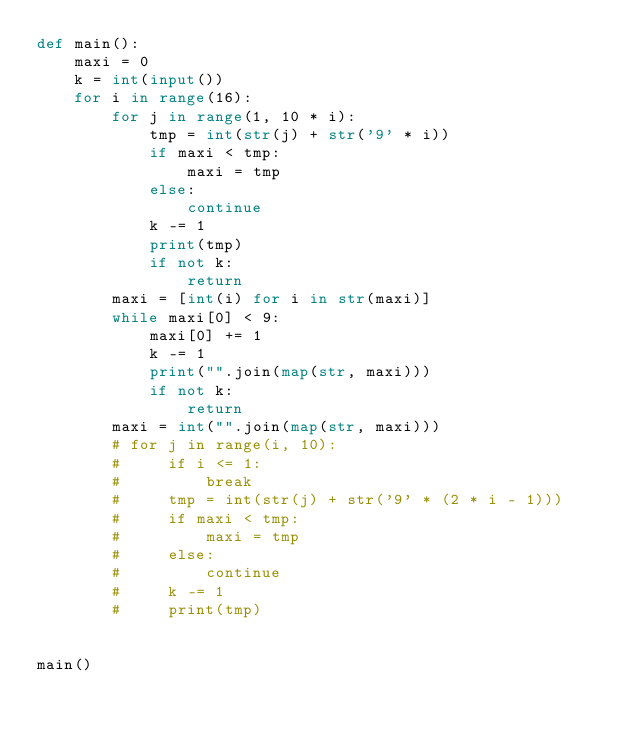Convert code to text. <code><loc_0><loc_0><loc_500><loc_500><_Python_>def main():
    maxi = 0
    k = int(input())
    for i in range(16):
        for j in range(1, 10 * i):
            tmp = int(str(j) + str('9' * i))
            if maxi < tmp:
                maxi = tmp
            else:
                continue
            k -= 1
            print(tmp)
            if not k:
                return
        maxi = [int(i) for i in str(maxi)]
        while maxi[0] < 9:
            maxi[0] += 1
            k -= 1
            print("".join(map(str, maxi)))
            if not k:
                return
        maxi = int("".join(map(str, maxi)))
        # for j in range(i, 10):
        #     if i <= 1:
        #         break
        #     tmp = int(str(j) + str('9' * (2 * i - 1)))
        #     if maxi < tmp:
        #         maxi = tmp
        #     else:
        #         continue
        #     k -= 1
        #     print(tmp)


main()
</code> 